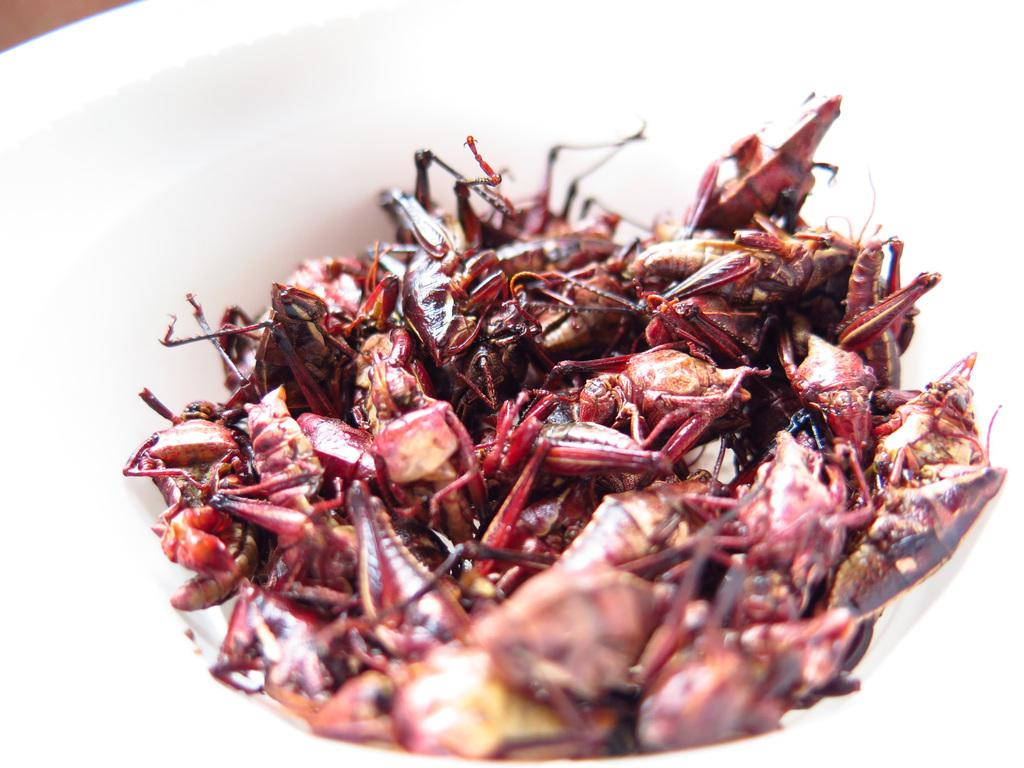What type of creatures are featured in the image? There are insects in the image. How are the insects prepared in the image? The insects are cooked. How are the cooked insects presented in the image? The insects are served in a bowl. What specific type of insects are depicted in the image? The insects appear to be grasshoppers. What reward does the daughter receive for joining the insect-eating contest in the image? There is no daughter or insect-eating contest present in the image. 